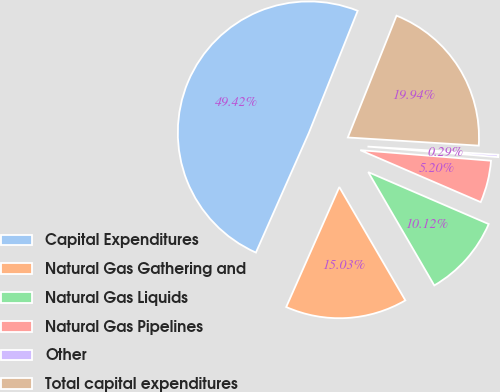Convert chart. <chart><loc_0><loc_0><loc_500><loc_500><pie_chart><fcel>Capital Expenditures<fcel>Natural Gas Gathering and<fcel>Natural Gas Liquids<fcel>Natural Gas Pipelines<fcel>Other<fcel>Total capital expenditures<nl><fcel>49.42%<fcel>15.03%<fcel>10.12%<fcel>5.2%<fcel>0.29%<fcel>19.94%<nl></chart> 